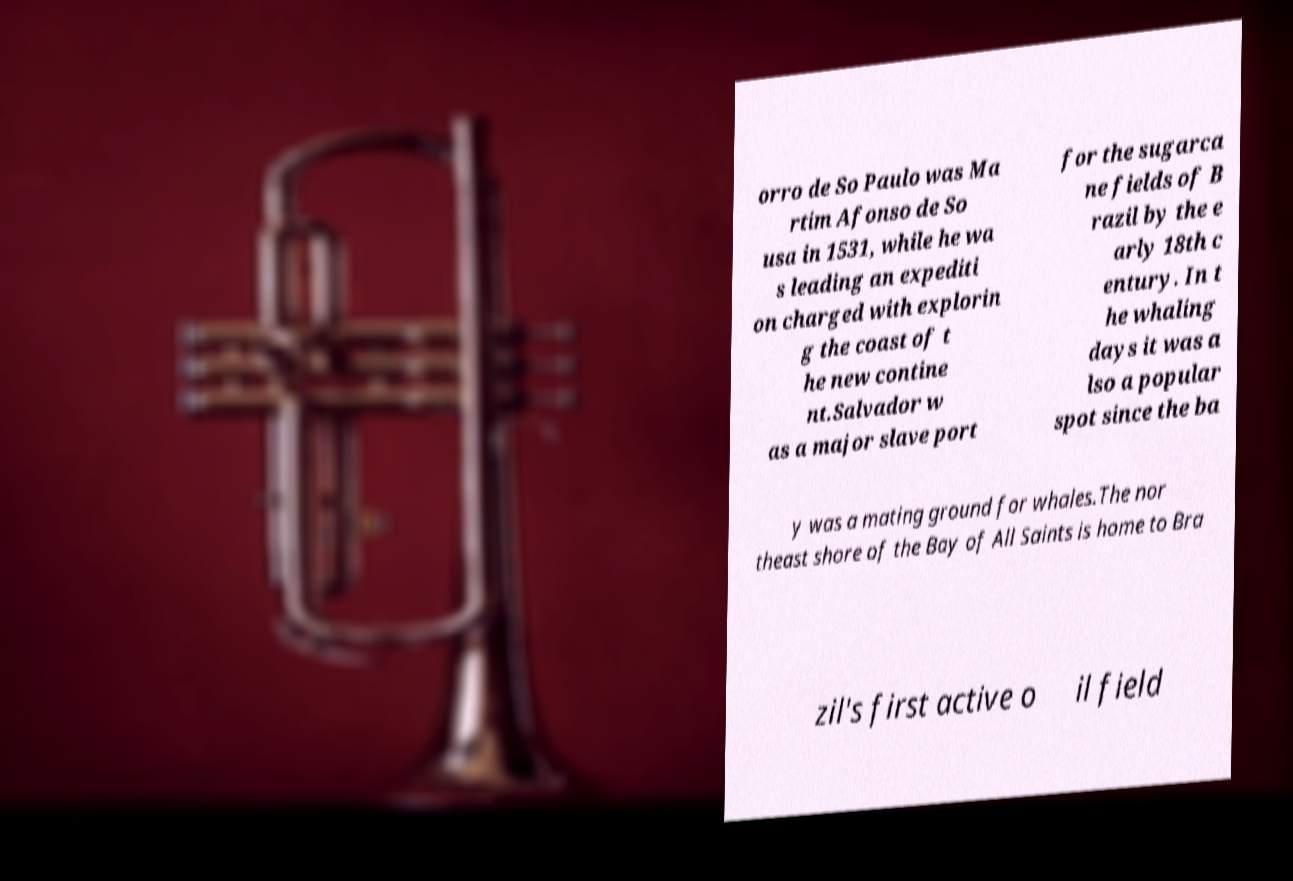There's text embedded in this image that I need extracted. Can you transcribe it verbatim? orro de So Paulo was Ma rtim Afonso de So usa in 1531, while he wa s leading an expediti on charged with explorin g the coast of t he new contine nt.Salvador w as a major slave port for the sugarca ne fields of B razil by the e arly 18th c entury. In t he whaling days it was a lso a popular spot since the ba y was a mating ground for whales.The nor theast shore of the Bay of All Saints is home to Bra zil's first active o il field 